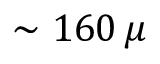Convert formula to latex. <formula><loc_0><loc_0><loc_500><loc_500>\sim 1 6 0 \, \mu</formula> 